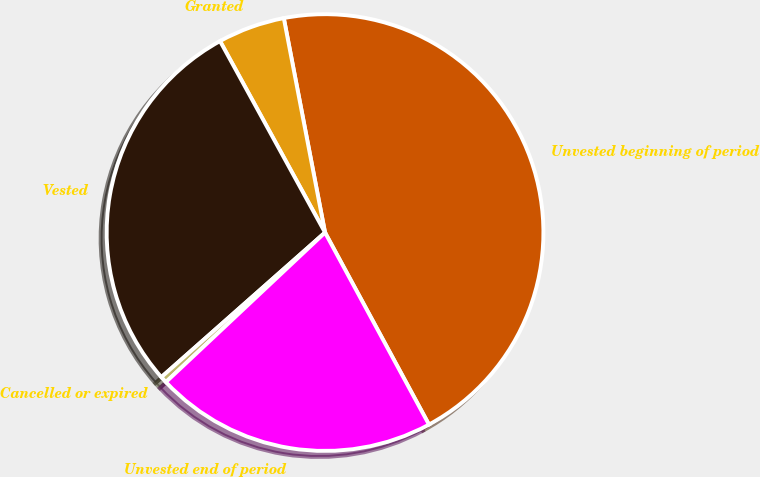Convert chart to OTSL. <chart><loc_0><loc_0><loc_500><loc_500><pie_chart><fcel>Unvested beginning of period<fcel>Granted<fcel>Vested<fcel>Cancelled or expired<fcel>Unvested end of period<nl><fcel>45.13%<fcel>4.96%<fcel>28.53%<fcel>0.49%<fcel>20.89%<nl></chart> 